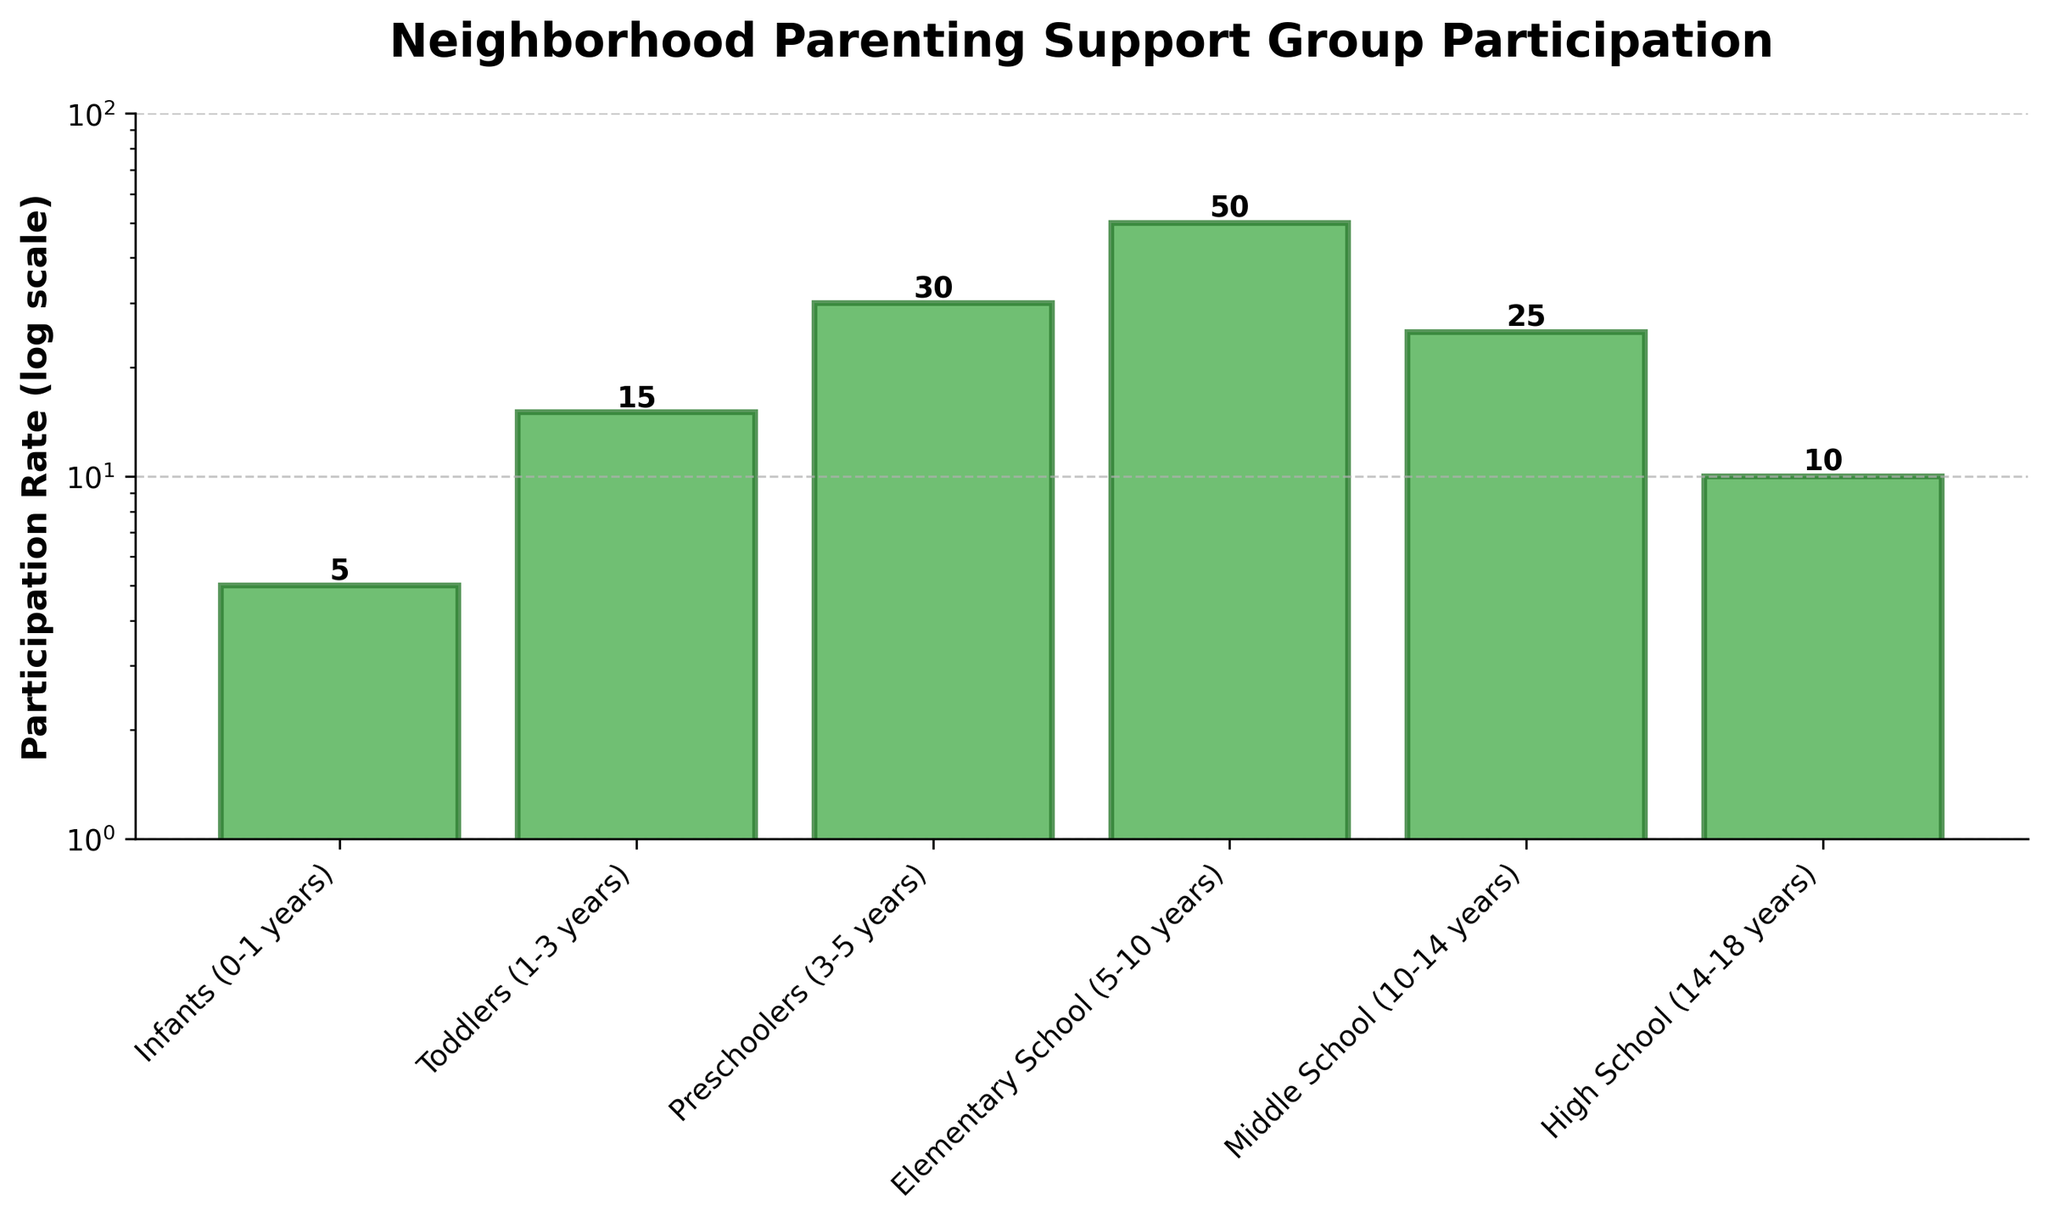What's the participation rate for toddlers (1-3 years)? From the figure, locate the bar labeled "Toddlers (1-3 years)" and read the participation rate value displayed above it.
Answer: 15% What's the sum of participation rates for infants (0-1 years) and preschoolers (3-5 years)? From the figure, find the participation rates for "Infants (0-1 years)" and "Preschoolers (3-5 years)" which are 5% and 30% respectively. Add these numbers together: 5 + 30 = 35.
Answer: 35% Which age category has the highest participation rate? Identify the tallest bar in the figure and read its label. The tallest bar represents "Elementary School (5-10 years)" with a participation rate of 50%.
Answer: Elementary School (5-10 years) How many age categories have a participation rate greater than 20%? Examine the figure and count the number of bars that exceed the 20% mark on the y-axis. "Preschoolers (3-5 years)" and "Elementary School (5-10 years)" are the two categories above 20%.
Answer: 2 What is the median participation rate for all the age categories? List the participation rates: 5%, 10%, 15%, 25%, 30%, 50%. The median is the middle value. Since there are an even number of data points, the median will be the average of the 3rd and 4th values, which are 15% and 25%. (15 + 25) / 2 = 20%.
Answer: 20% Is the participation rate for high school (14-18 years) less than that of middle school (10-14 years)? Compare the heights of the bars for "High School (14-18 years)" and "Middle School (10-14 years)". The participation rate for "High School (14-18 years)" is 10%, while for "Middle School (10-14 years)" it is 25%. Yes, 10 is less than 25.
Answer: Yes What's the difference in participation rates between preschoolers (3-5 years) and high school (14-18 years)? Read the participation rates for "Preschoolers (3-5 years)" and "High School (14-18 years)" from the figure, which are 30% and 10% respectively. Subtract the latter from the former: 30 - 10 = 20.
Answer: 20% What can you infer about participation trends as children age from infants to high school? Observe the changing heights of the bars from left to right in the figure. Participation rates start low for infants, increase to a peak for elementary school children, and then generally decrease for middle and high school students. This suggests participation tends to be higher for younger children and decreases as children get older.
Answer: Higher when children are younger How does using a log scale affect the visual representation of participation rates? A logarithmic scale compresses the range of values, making smaller values appear closer together and larger values spread out. This helps to visualize differences when data spans several orders of magnitude. The differences between lower participation rates (e.g., 5% vs. 10%) are more discernible, and larger values (like 50%) don't dominate the visualization.
Answer: Shows spreads clearer 